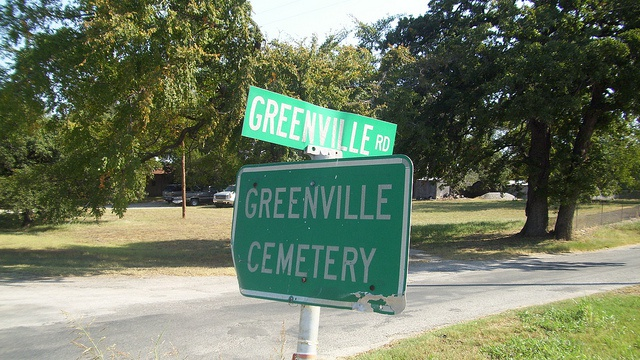Describe the objects in this image and their specific colors. I can see car in lightblue, black, gray, and purple tones and car in lightblue, gray, black, white, and darkgray tones in this image. 